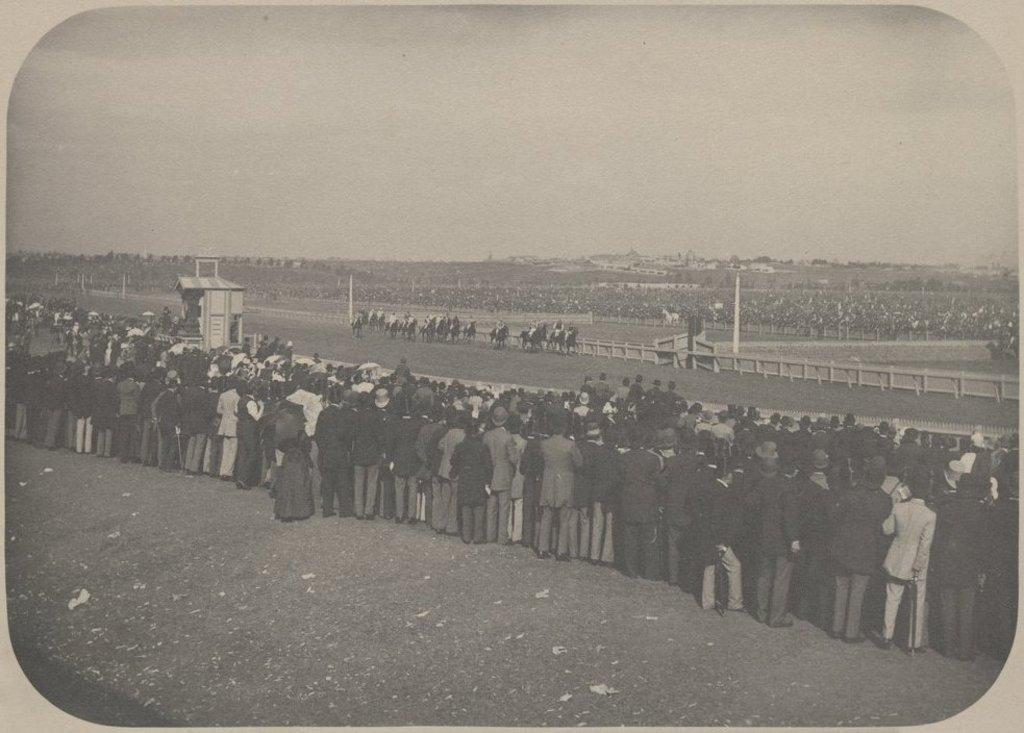In one or two sentences, can you explain what this image depicts? In this image we can see a photo frame. And this is a black and white image. And we can see many people. Also there are horses. And there are poles. In the background there is sky. 